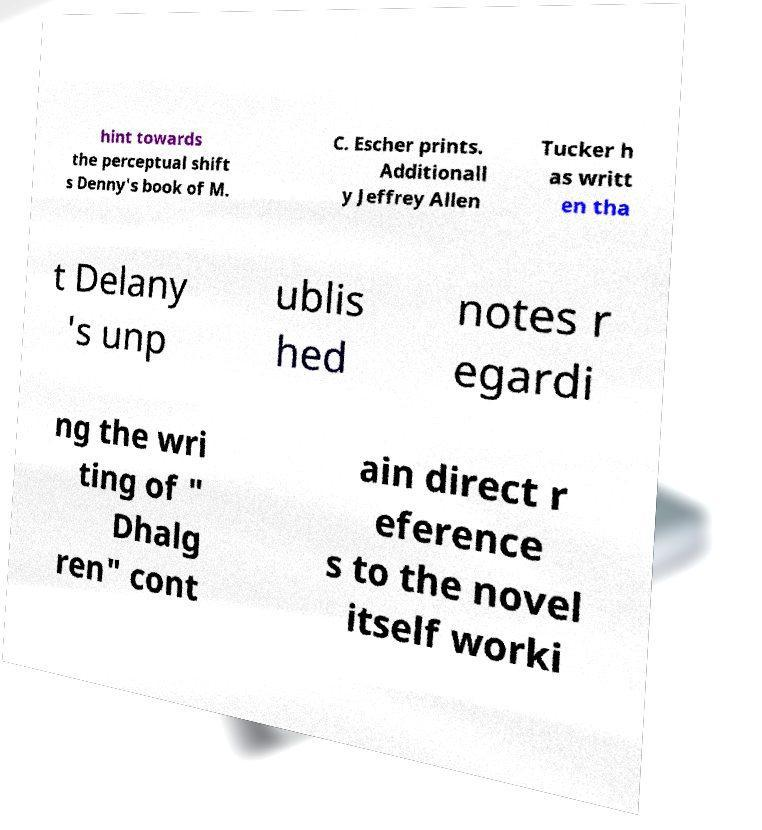What messages or text are displayed in this image? I need them in a readable, typed format. hint towards the perceptual shift s Denny's book of M. C. Escher prints. Additionall y Jeffrey Allen Tucker h as writt en tha t Delany 's unp ublis hed notes r egardi ng the wri ting of " Dhalg ren" cont ain direct r eference s to the novel itself worki 